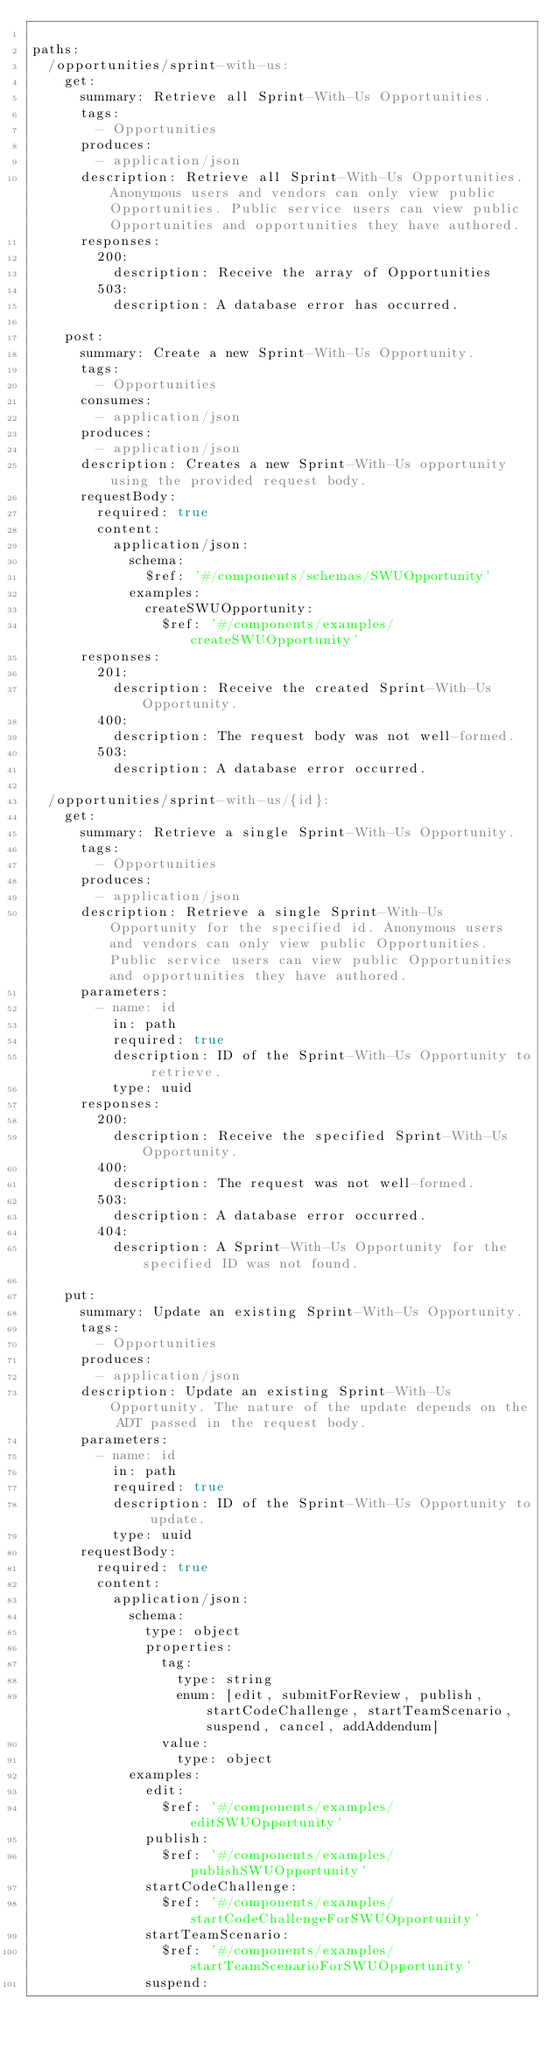<code> <loc_0><loc_0><loc_500><loc_500><_YAML_>
paths:
  /opportunities/sprint-with-us:
    get:
      summary: Retrieve all Sprint-With-Us Opportunities.
      tags:
        - Opportunities
      produces:
        - application/json
      description: Retrieve all Sprint-With-Us Opportunities. Anonymous users and vendors can only view public Opportunities. Public service users can view public Opportunities and opportunities they have authored.
      responses:
        200:
          description: Receive the array of Opportunities
        503:
          description: A database error has occurred.

    post:
      summary: Create a new Sprint-With-Us Opportunity.
      tags:
        - Opportunities
      consumes:
        - application/json
      produces:
        - application/json
      description: Creates a new Sprint-With-Us opportunity using the provided request body.
      requestBody:
        required: true
        content:
          application/json:
            schema:
              $ref: '#/components/schemas/SWUOpportunity'
            examples:
              createSWUOpportunity:
                $ref: '#/components/examples/createSWUOpportunity'
      responses:
        201:
          description: Receive the created Sprint-With-Us Opportunity.
        400:
          description: The request body was not well-formed.
        503:
          description: A database error occurred.

  /opportunities/sprint-with-us/{id}:
    get:
      summary: Retrieve a single Sprint-With-Us Opportunity.
      tags:
        - Opportunities
      produces:
        - application/json
      description: Retrieve a single Sprint-With-Us Opportunity for the specified id. Anonymous users and vendors can only view public Opportunities. Public service users can view public Opportunities and opportunities they have authored. 
      parameters:
        - name: id
          in: path
          required: true
          description: ID of the Sprint-With-Us Opportunity to retrieve.
          type: uuid
      responses:
        200:
          description: Receive the specified Sprint-With-Us Opportunity.
        400:
          description: The request was not well-formed.
        503:
          description: A database error occurred.
        404:
          description: A Sprint-With-Us Opportunity for the specified ID was not found.
    
    put:
      summary: Update an existing Sprint-With-Us Opportunity.
      tags:
        - Opportunities
      produces:
        - application/json
      description: Update an existing Sprint-With-Us Opportunity. The nature of the update depends on the ADT passed in the request body.
      parameters:
        - name: id
          in: path
          required: true
          description: ID of the Sprint-With-Us Opportunity to update.
          type: uuid
      requestBody:
        required: true
        content:
          application/json:
            schema:
              type: object
              properties:
                tag:
                  type: string
                  enum: [edit, submitForReview, publish, startCodeChallenge, startTeamScenario, suspend, cancel, addAddendum]
                value:
                  type: object
            examples:
              edit:
                $ref: '#/components/examples/editSWUOpportunity'
              publish:
                $ref: '#/components/examples/publishSWUOpportunity'
              startCodeChallenge:
                $ref: '#/components/examples/startCodeChallengeForSWUOpportunity'
              startTeamScenario:
                $ref: '#/components/examples/startTeamScenarioForSWUOpportunity'
              suspend:</code> 